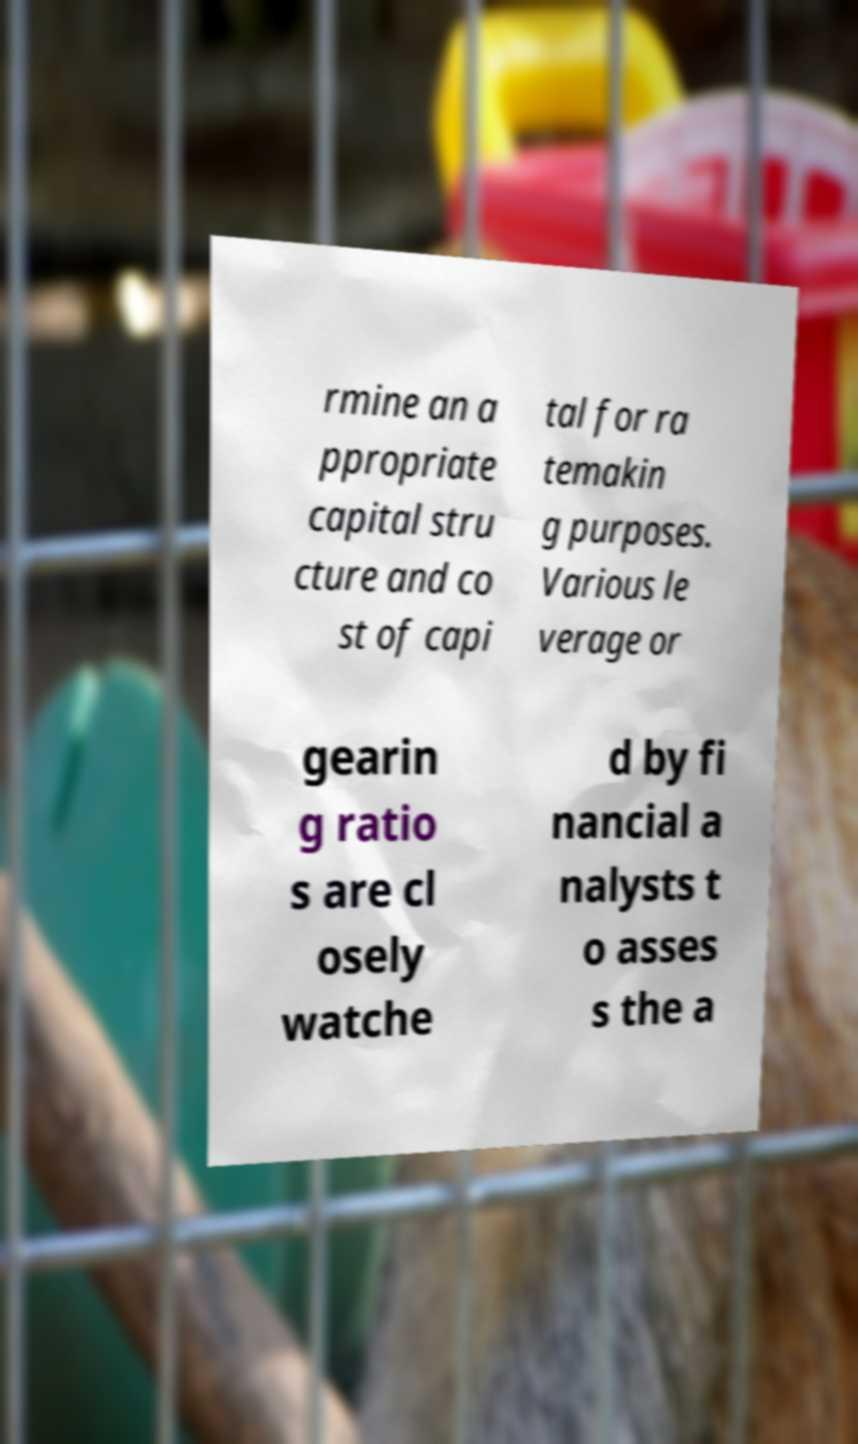Can you read and provide the text displayed in the image?This photo seems to have some interesting text. Can you extract and type it out for me? rmine an a ppropriate capital stru cture and co st of capi tal for ra temakin g purposes. Various le verage or gearin g ratio s are cl osely watche d by fi nancial a nalysts t o asses s the a 